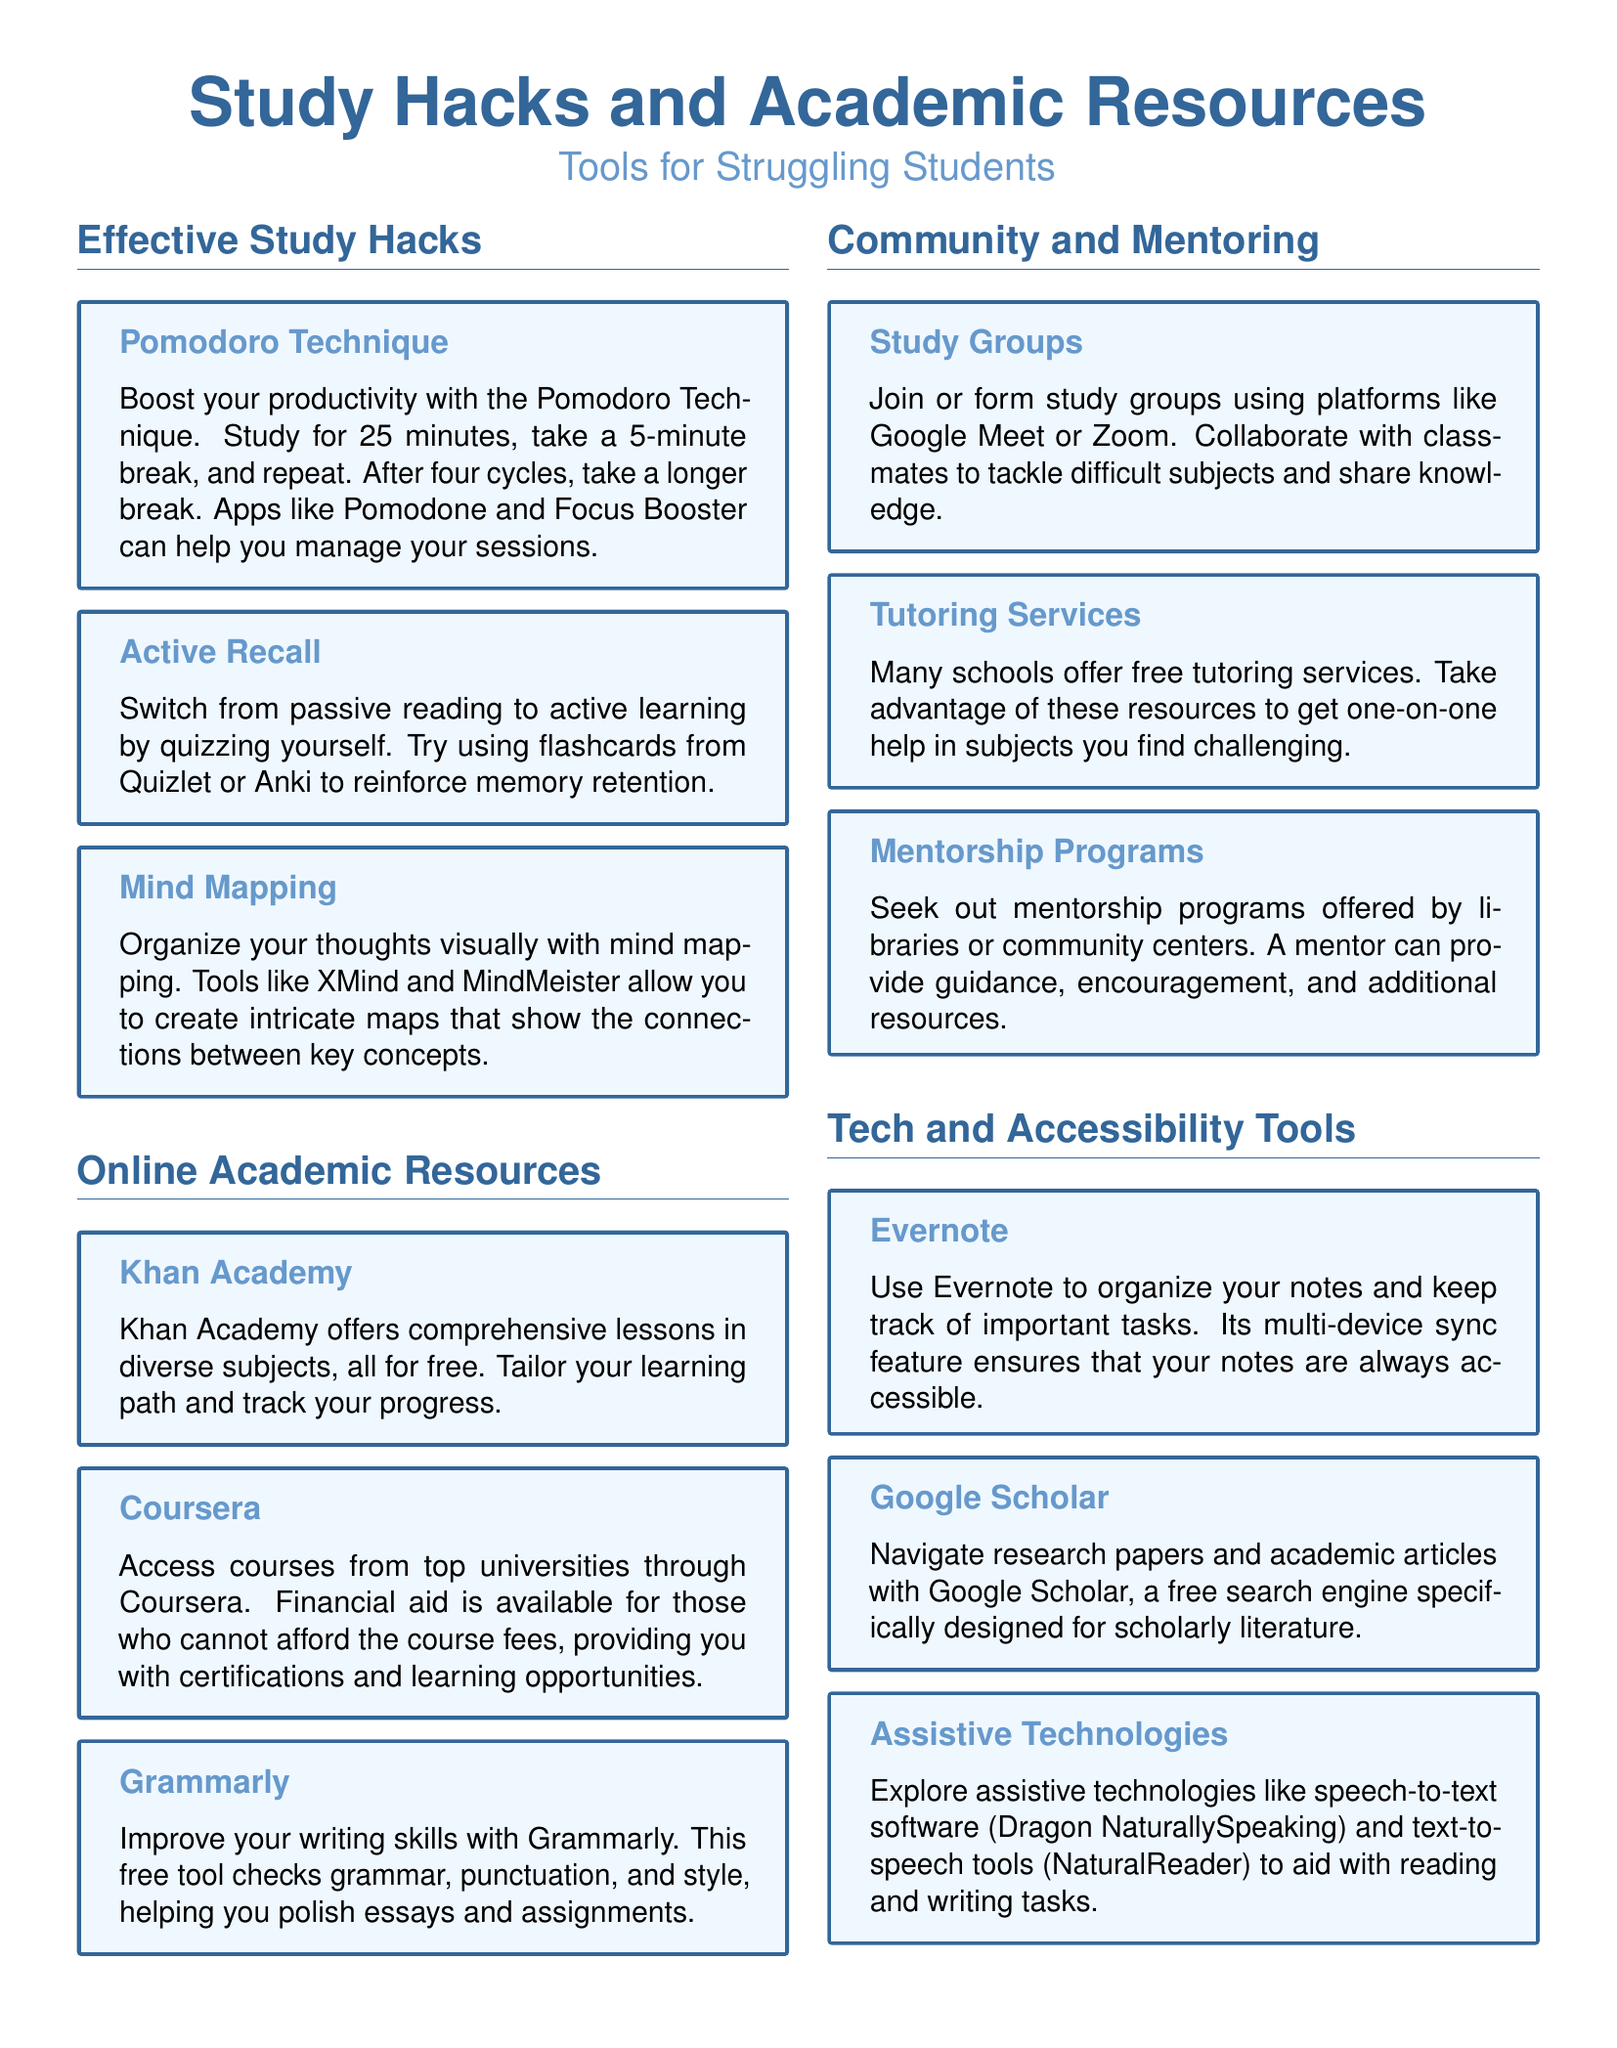What is the first study hack mentioned? The first study hack in the document is the Pomodoro Technique, which boosts productivity.
Answer: Pomodoro Technique Which online resource offers comprehensive lessons for free? The document states that Khan Academy offers comprehensive lessons in diverse subjects, all for free.
Answer: Khan Academy How long should each Pomodoro session last? According to the document, each Pomodoro session should last for 25 minutes.
Answer: 25 minutes What tool is recommended for improving writing skills? The document suggests using Grammarly to improve writing skills by checking grammar, punctuation, and style.
Answer: Grammarly What platforms can be used to join study groups? The document mentions using platforms like Google Meet or Zoom to join or form study groups.
Answer: Google Meet, Zoom How can students access courses from top universities? The document indicates that students can access courses from top universities through Coursera, which also offers financial aid.
Answer: Coursera What assistive technology helps with reading tasks? Dragon NaturallySpeaking is mentioned in the document as a speech-to-text software that aids with reading tasks.
Answer: Dragon NaturallySpeaking What is a benefit of forming study groups? Forming study groups allows collaboration with classmates to tackle difficult subjects and share knowledge.
Answer: Collaboration What tool helps organize notes? The document states that Evernote is a tool used to organize notes and keep track of important tasks.
Answer: Evernote 